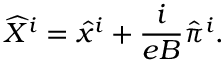Convert formula to latex. <formula><loc_0><loc_0><loc_500><loc_500>\widehat { X } ^ { i } = \hat { x } ^ { i } + \frac { i } { e B } \hat { \pi } ^ { i } .</formula> 